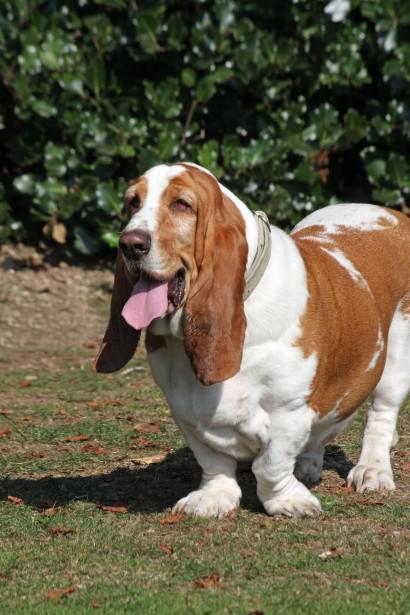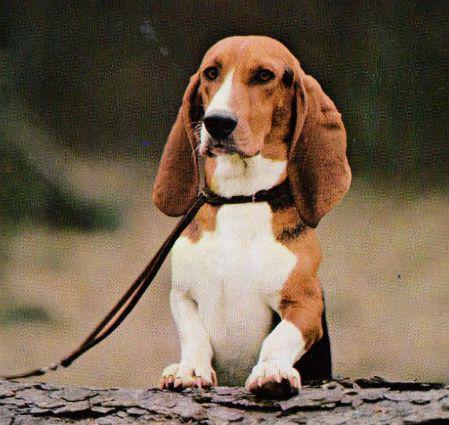The first image is the image on the left, the second image is the image on the right. Analyze the images presented: Is the assertion "One of the images shows a dog on a bench." valid? Answer yes or no. No. 